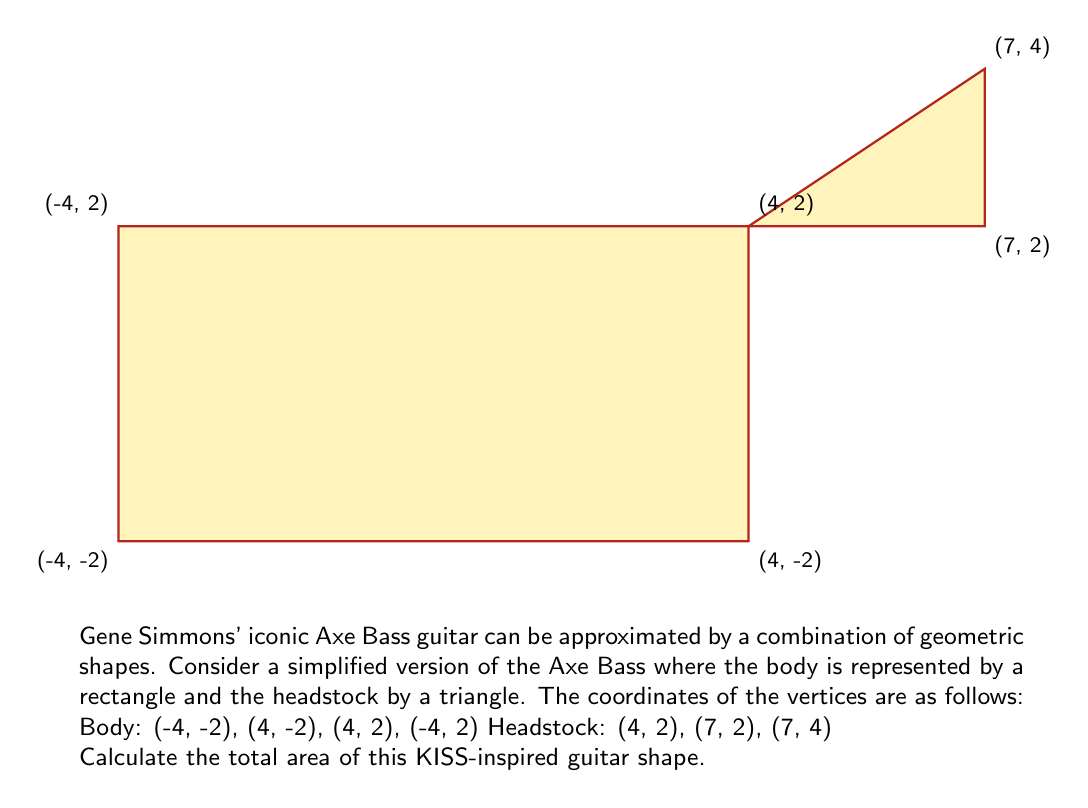Can you answer this question? Let's break this down step-by-step:

1) First, we need to calculate the area of the rectangular body:
   Width = 4 - (-4) = 8
   Height = 2 - (-2) = 4
   Area of rectangle = $8 \times 4 = 32$ square units

2) Now, let's calculate the area of the triangular headstock:
   Base = 7 - 4 = 3
   Height = 4 - 2 = 2
   Area of triangle = $\frac{1}{2} \times base \times height = \frac{1}{2} \times 3 \times 2 = 3$ square units

3) The total area is the sum of these two areas:
   Total Area = Area of rectangle + Area of triangle
               = $32 + 3 = 35$ square units

Therefore, the total area of the KISS-inspired Axe Bass guitar shape is 35 square units.
Answer: 35 square units 